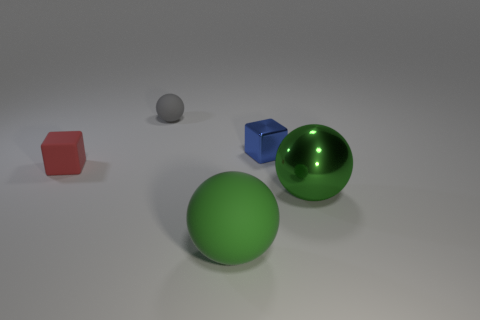Are there an equal number of tiny blue metallic things that are to the right of the blue block and big metallic objects left of the tiny red cube?
Offer a very short reply. Yes. What color is the thing that is both to the left of the tiny blue metallic cube and in front of the small red thing?
Your response must be concise. Green. Are there any other things that have the same size as the red rubber object?
Offer a terse response. Yes. Are there more large green things left of the large shiny ball than green metal balls that are behind the small matte cube?
Your response must be concise. Yes. There is a matte thing that is behind the blue thing; does it have the same size as the red object?
Offer a very short reply. Yes. How many rubber balls are right of the large green thing on the right side of the sphere in front of the green metal ball?
Ensure brevity in your answer.  0. There is a object that is right of the green matte object and behind the green metallic thing; what size is it?
Ensure brevity in your answer.  Small. How many other objects are the same shape as the gray thing?
Offer a very short reply. 2. What number of small matte objects are to the left of the large metal sphere?
Provide a short and direct response. 2. Are there fewer matte things behind the tiny blue object than small cubes to the right of the metallic ball?
Provide a succinct answer. No. 